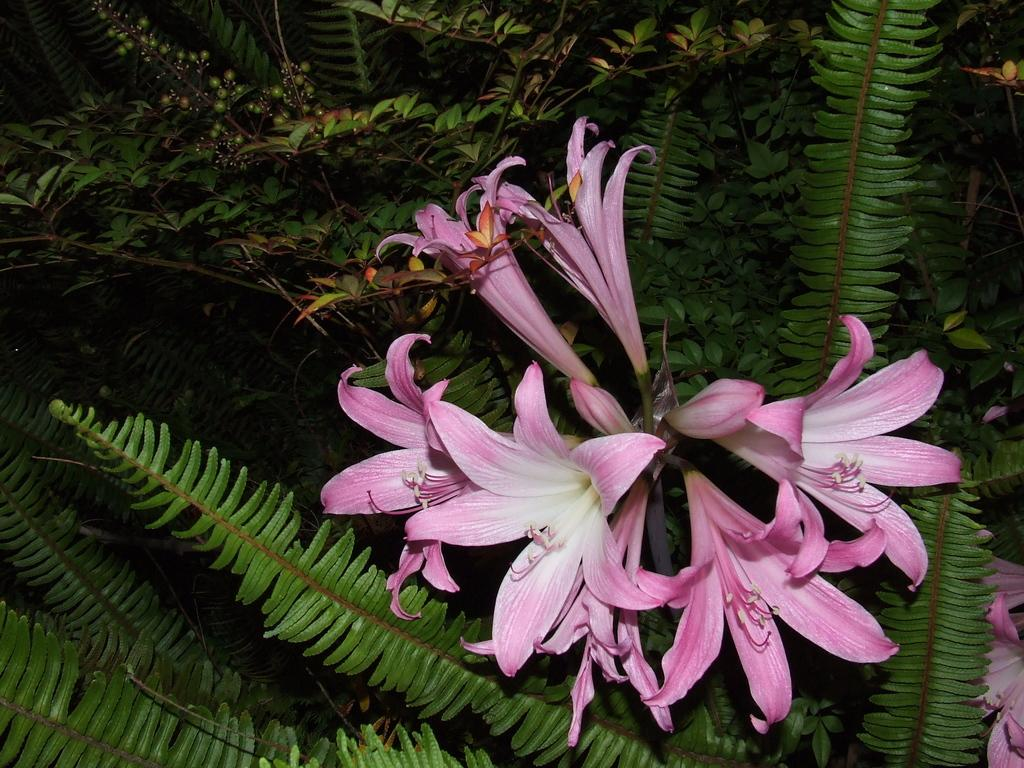What type of flowers can be seen in the image? There are lily flowers in the image. What else can be seen in the image besides the lily flowers? There are many other plants in the image. What type of dirt can be seen on the train in the image? There is no train present in the image, so there is no dirt to be seen on it. 